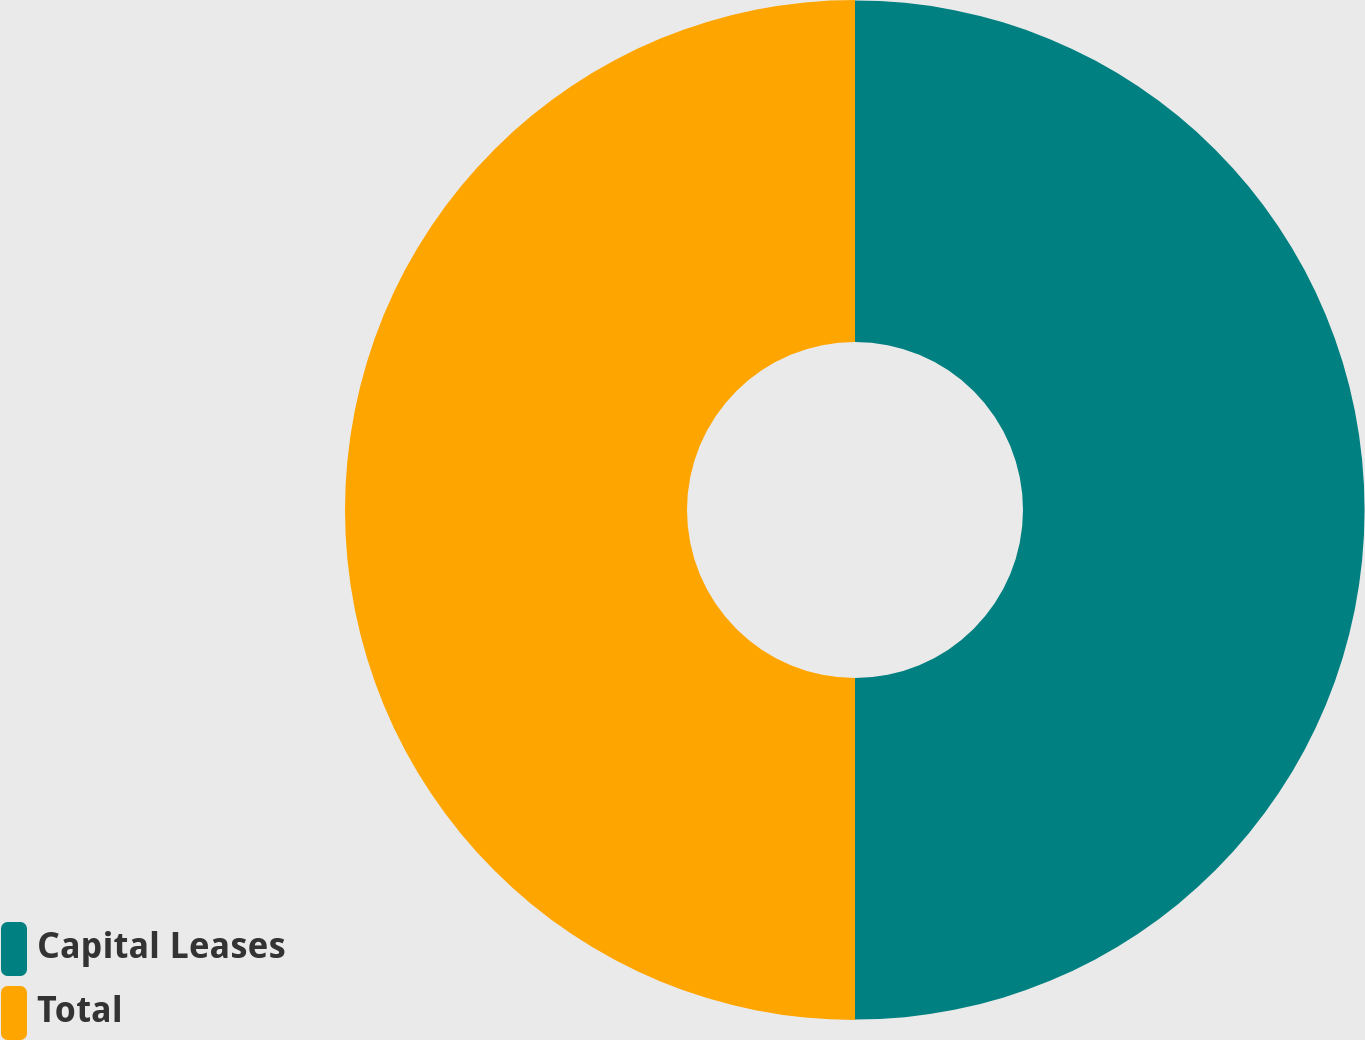Convert chart to OTSL. <chart><loc_0><loc_0><loc_500><loc_500><pie_chart><fcel>Capital Leases<fcel>Total<nl><fcel>49.97%<fcel>50.03%<nl></chart> 